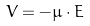Convert formula to latex. <formula><loc_0><loc_0><loc_500><loc_500>V = - { \mu \cdot E }</formula> 